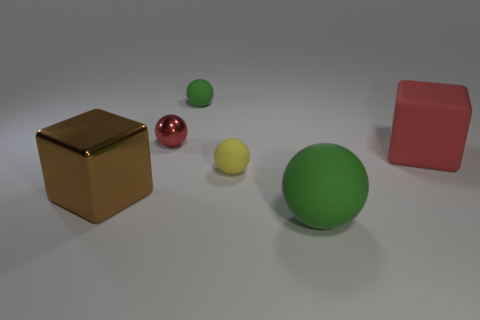Is the number of metallic spheres that are on the right side of the big red matte object less than the number of big brown things on the right side of the brown object?
Keep it short and to the point. No. Do the yellow rubber ball and the sphere that is behind the tiny metal object have the same size?
Give a very brief answer. Yes. How many yellow objects are either large cubes or tiny objects?
Make the answer very short. 1. Are the object to the left of the tiny metal thing and the tiny yellow sphere made of the same material?
Offer a very short reply. No. What number of other objects are there of the same material as the big sphere?
Offer a very short reply. 3. What is the yellow ball made of?
Provide a succinct answer. Rubber. There is a green sphere that is in front of the metal block; what is its size?
Your answer should be very brief. Large. There is a big block on the right side of the red metal ball; what number of rubber things are behind it?
Provide a succinct answer. 1. There is a small thing that is behind the metal ball; does it have the same shape as the green thing on the right side of the yellow matte object?
Offer a very short reply. Yes. What number of small spheres are both behind the small red thing and in front of the small metal ball?
Offer a terse response. 0. 